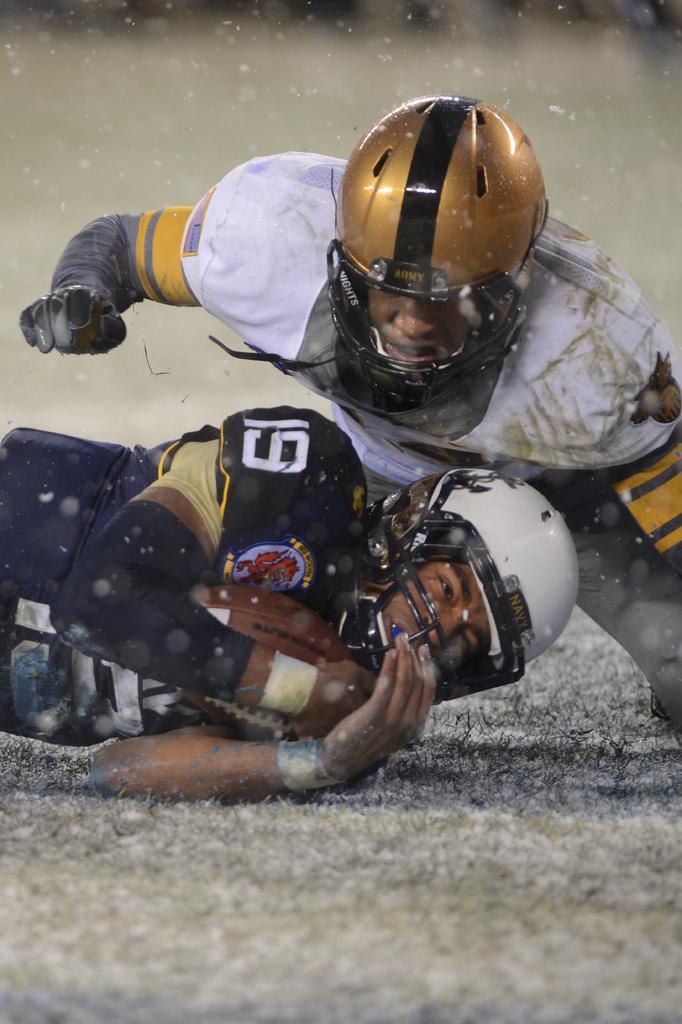Please provide a concise description of this image. In this image, we can see two persons wearing clothes and helmets. The person who is on the left side of the image holding a ball with his hands. In the background, image is blurred. 